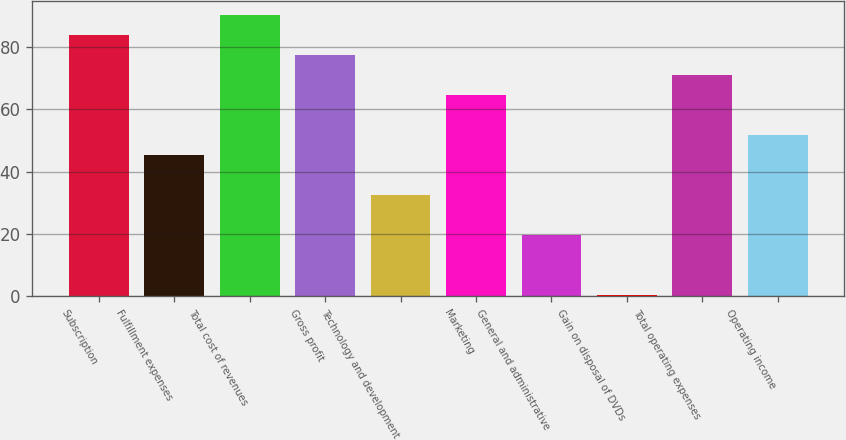<chart> <loc_0><loc_0><loc_500><loc_500><bar_chart><fcel>Subscription<fcel>Fulfillment expenses<fcel>Total cost of revenues<fcel>Gross profit<fcel>Technology and development<fcel>Marketing<fcel>General and administrative<fcel>Gain on disposal of DVDs<fcel>Total operating expenses<fcel>Operating income<nl><fcel>83.89<fcel>45.31<fcel>90.32<fcel>77.46<fcel>32.45<fcel>64.6<fcel>19.59<fcel>0.3<fcel>71.03<fcel>51.74<nl></chart> 